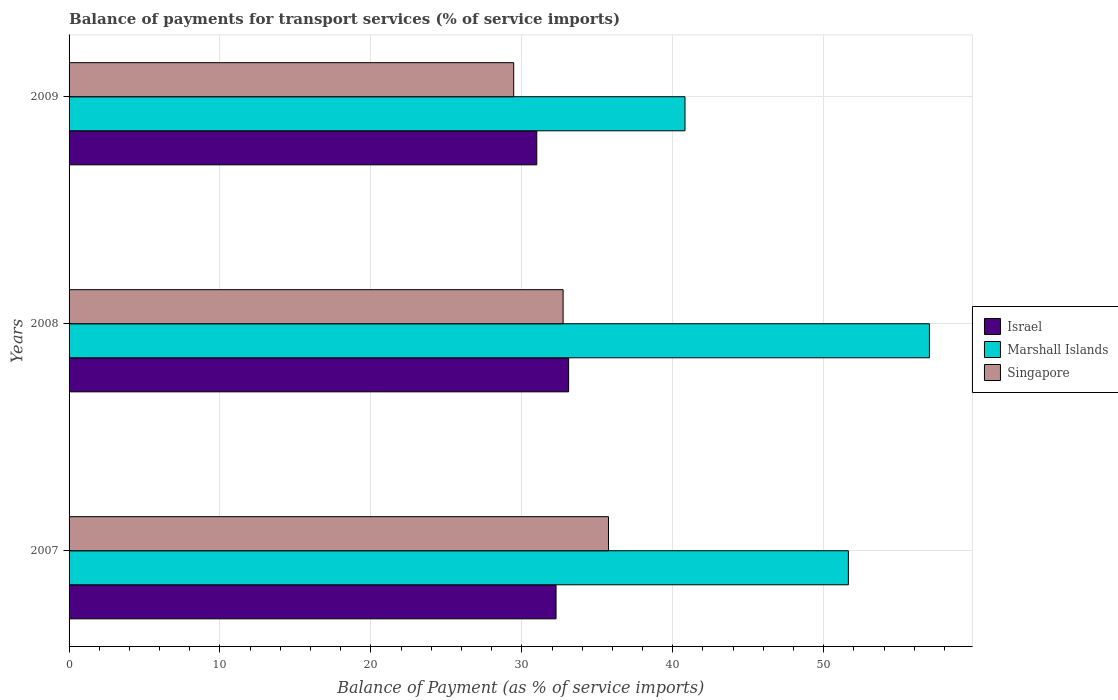How many different coloured bars are there?
Your response must be concise. 3. Are the number of bars per tick equal to the number of legend labels?
Give a very brief answer. Yes. How many bars are there on the 1st tick from the bottom?
Keep it short and to the point. 3. In how many cases, is the number of bars for a given year not equal to the number of legend labels?
Offer a terse response. 0. What is the balance of payments for transport services in Singapore in 2008?
Your response must be concise. 32.74. Across all years, what is the maximum balance of payments for transport services in Singapore?
Keep it short and to the point. 35.74. Across all years, what is the minimum balance of payments for transport services in Israel?
Your response must be concise. 30.99. In which year was the balance of payments for transport services in Marshall Islands maximum?
Your answer should be very brief. 2008. What is the total balance of payments for transport services in Marshall Islands in the graph?
Make the answer very short. 149.46. What is the difference between the balance of payments for transport services in Marshall Islands in 2007 and that in 2008?
Make the answer very short. -5.37. What is the difference between the balance of payments for transport services in Singapore in 2009 and the balance of payments for transport services in Israel in 2008?
Offer a very short reply. -3.64. What is the average balance of payments for transport services in Israel per year?
Your response must be concise. 32.12. In the year 2008, what is the difference between the balance of payments for transport services in Israel and balance of payments for transport services in Marshall Islands?
Ensure brevity in your answer.  -23.91. In how many years, is the balance of payments for transport services in Singapore greater than 40 %?
Keep it short and to the point. 0. What is the ratio of the balance of payments for transport services in Singapore in 2008 to that in 2009?
Offer a terse response. 1.11. Is the difference between the balance of payments for transport services in Israel in 2007 and 2009 greater than the difference between the balance of payments for transport services in Marshall Islands in 2007 and 2009?
Provide a succinct answer. No. What is the difference between the highest and the second highest balance of payments for transport services in Israel?
Give a very brief answer. 0.83. What is the difference between the highest and the lowest balance of payments for transport services in Marshall Islands?
Offer a very short reply. 16.2. In how many years, is the balance of payments for transport services in Israel greater than the average balance of payments for transport services in Israel taken over all years?
Your response must be concise. 2. What does the 1st bar from the top in 2009 represents?
Keep it short and to the point. Singapore. How many bars are there?
Give a very brief answer. 9. Are all the bars in the graph horizontal?
Provide a short and direct response. Yes. Does the graph contain any zero values?
Give a very brief answer. No. Does the graph contain grids?
Keep it short and to the point. Yes. How many legend labels are there?
Give a very brief answer. 3. What is the title of the graph?
Your answer should be compact. Balance of payments for transport services (% of service imports). What is the label or title of the X-axis?
Keep it short and to the point. Balance of Payment (as % of service imports). What is the label or title of the Y-axis?
Provide a short and direct response. Years. What is the Balance of Payment (as % of service imports) of Israel in 2007?
Keep it short and to the point. 32.27. What is the Balance of Payment (as % of service imports) of Marshall Islands in 2007?
Make the answer very short. 51.64. What is the Balance of Payment (as % of service imports) of Singapore in 2007?
Provide a short and direct response. 35.74. What is the Balance of Payment (as % of service imports) of Israel in 2008?
Ensure brevity in your answer.  33.1. What is the Balance of Payment (as % of service imports) of Marshall Islands in 2008?
Give a very brief answer. 57.01. What is the Balance of Payment (as % of service imports) in Singapore in 2008?
Offer a very short reply. 32.74. What is the Balance of Payment (as % of service imports) in Israel in 2009?
Provide a succinct answer. 30.99. What is the Balance of Payment (as % of service imports) in Marshall Islands in 2009?
Offer a terse response. 40.81. What is the Balance of Payment (as % of service imports) in Singapore in 2009?
Provide a short and direct response. 29.46. Across all years, what is the maximum Balance of Payment (as % of service imports) of Israel?
Provide a succinct answer. 33.1. Across all years, what is the maximum Balance of Payment (as % of service imports) of Marshall Islands?
Offer a terse response. 57.01. Across all years, what is the maximum Balance of Payment (as % of service imports) of Singapore?
Your answer should be very brief. 35.74. Across all years, what is the minimum Balance of Payment (as % of service imports) in Israel?
Offer a terse response. 30.99. Across all years, what is the minimum Balance of Payment (as % of service imports) of Marshall Islands?
Make the answer very short. 40.81. Across all years, what is the minimum Balance of Payment (as % of service imports) of Singapore?
Your response must be concise. 29.46. What is the total Balance of Payment (as % of service imports) in Israel in the graph?
Your answer should be compact. 96.36. What is the total Balance of Payment (as % of service imports) of Marshall Islands in the graph?
Provide a succinct answer. 149.46. What is the total Balance of Payment (as % of service imports) of Singapore in the graph?
Make the answer very short. 97.94. What is the difference between the Balance of Payment (as % of service imports) of Israel in 2007 and that in 2008?
Keep it short and to the point. -0.83. What is the difference between the Balance of Payment (as % of service imports) in Marshall Islands in 2007 and that in 2008?
Ensure brevity in your answer.  -5.37. What is the difference between the Balance of Payment (as % of service imports) of Singapore in 2007 and that in 2008?
Offer a very short reply. 3.01. What is the difference between the Balance of Payment (as % of service imports) in Israel in 2007 and that in 2009?
Offer a very short reply. 1.28. What is the difference between the Balance of Payment (as % of service imports) in Marshall Islands in 2007 and that in 2009?
Provide a succinct answer. 10.83. What is the difference between the Balance of Payment (as % of service imports) in Singapore in 2007 and that in 2009?
Your answer should be very brief. 6.28. What is the difference between the Balance of Payment (as % of service imports) in Israel in 2008 and that in 2009?
Offer a very short reply. 2.11. What is the difference between the Balance of Payment (as % of service imports) in Marshall Islands in 2008 and that in 2009?
Give a very brief answer. 16.2. What is the difference between the Balance of Payment (as % of service imports) of Singapore in 2008 and that in 2009?
Keep it short and to the point. 3.27. What is the difference between the Balance of Payment (as % of service imports) in Israel in 2007 and the Balance of Payment (as % of service imports) in Marshall Islands in 2008?
Keep it short and to the point. -24.74. What is the difference between the Balance of Payment (as % of service imports) of Israel in 2007 and the Balance of Payment (as % of service imports) of Singapore in 2008?
Make the answer very short. -0.47. What is the difference between the Balance of Payment (as % of service imports) in Marshall Islands in 2007 and the Balance of Payment (as % of service imports) in Singapore in 2008?
Make the answer very short. 18.9. What is the difference between the Balance of Payment (as % of service imports) of Israel in 2007 and the Balance of Payment (as % of service imports) of Marshall Islands in 2009?
Keep it short and to the point. -8.54. What is the difference between the Balance of Payment (as % of service imports) of Israel in 2007 and the Balance of Payment (as % of service imports) of Singapore in 2009?
Offer a very short reply. 2.81. What is the difference between the Balance of Payment (as % of service imports) of Marshall Islands in 2007 and the Balance of Payment (as % of service imports) of Singapore in 2009?
Provide a short and direct response. 22.18. What is the difference between the Balance of Payment (as % of service imports) of Israel in 2008 and the Balance of Payment (as % of service imports) of Marshall Islands in 2009?
Provide a succinct answer. -7.71. What is the difference between the Balance of Payment (as % of service imports) of Israel in 2008 and the Balance of Payment (as % of service imports) of Singapore in 2009?
Give a very brief answer. 3.64. What is the difference between the Balance of Payment (as % of service imports) in Marshall Islands in 2008 and the Balance of Payment (as % of service imports) in Singapore in 2009?
Offer a very short reply. 27.55. What is the average Balance of Payment (as % of service imports) of Israel per year?
Provide a short and direct response. 32.12. What is the average Balance of Payment (as % of service imports) in Marshall Islands per year?
Provide a succinct answer. 49.82. What is the average Balance of Payment (as % of service imports) in Singapore per year?
Offer a very short reply. 32.65. In the year 2007, what is the difference between the Balance of Payment (as % of service imports) of Israel and Balance of Payment (as % of service imports) of Marshall Islands?
Your response must be concise. -19.37. In the year 2007, what is the difference between the Balance of Payment (as % of service imports) of Israel and Balance of Payment (as % of service imports) of Singapore?
Offer a terse response. -3.47. In the year 2007, what is the difference between the Balance of Payment (as % of service imports) of Marshall Islands and Balance of Payment (as % of service imports) of Singapore?
Give a very brief answer. 15.9. In the year 2008, what is the difference between the Balance of Payment (as % of service imports) in Israel and Balance of Payment (as % of service imports) in Marshall Islands?
Offer a very short reply. -23.91. In the year 2008, what is the difference between the Balance of Payment (as % of service imports) of Israel and Balance of Payment (as % of service imports) of Singapore?
Offer a very short reply. 0.36. In the year 2008, what is the difference between the Balance of Payment (as % of service imports) of Marshall Islands and Balance of Payment (as % of service imports) of Singapore?
Your response must be concise. 24.27. In the year 2009, what is the difference between the Balance of Payment (as % of service imports) of Israel and Balance of Payment (as % of service imports) of Marshall Islands?
Ensure brevity in your answer.  -9.82. In the year 2009, what is the difference between the Balance of Payment (as % of service imports) of Israel and Balance of Payment (as % of service imports) of Singapore?
Provide a short and direct response. 1.53. In the year 2009, what is the difference between the Balance of Payment (as % of service imports) of Marshall Islands and Balance of Payment (as % of service imports) of Singapore?
Your answer should be very brief. 11.35. What is the ratio of the Balance of Payment (as % of service imports) of Israel in 2007 to that in 2008?
Make the answer very short. 0.97. What is the ratio of the Balance of Payment (as % of service imports) in Marshall Islands in 2007 to that in 2008?
Your answer should be very brief. 0.91. What is the ratio of the Balance of Payment (as % of service imports) in Singapore in 2007 to that in 2008?
Your response must be concise. 1.09. What is the ratio of the Balance of Payment (as % of service imports) in Israel in 2007 to that in 2009?
Offer a very short reply. 1.04. What is the ratio of the Balance of Payment (as % of service imports) in Marshall Islands in 2007 to that in 2009?
Your response must be concise. 1.27. What is the ratio of the Balance of Payment (as % of service imports) of Singapore in 2007 to that in 2009?
Make the answer very short. 1.21. What is the ratio of the Balance of Payment (as % of service imports) of Israel in 2008 to that in 2009?
Make the answer very short. 1.07. What is the ratio of the Balance of Payment (as % of service imports) in Marshall Islands in 2008 to that in 2009?
Your answer should be very brief. 1.4. What is the ratio of the Balance of Payment (as % of service imports) in Singapore in 2008 to that in 2009?
Provide a short and direct response. 1.11. What is the difference between the highest and the second highest Balance of Payment (as % of service imports) of Marshall Islands?
Provide a short and direct response. 5.37. What is the difference between the highest and the second highest Balance of Payment (as % of service imports) in Singapore?
Offer a terse response. 3.01. What is the difference between the highest and the lowest Balance of Payment (as % of service imports) in Israel?
Your answer should be compact. 2.11. What is the difference between the highest and the lowest Balance of Payment (as % of service imports) in Marshall Islands?
Make the answer very short. 16.2. What is the difference between the highest and the lowest Balance of Payment (as % of service imports) of Singapore?
Give a very brief answer. 6.28. 